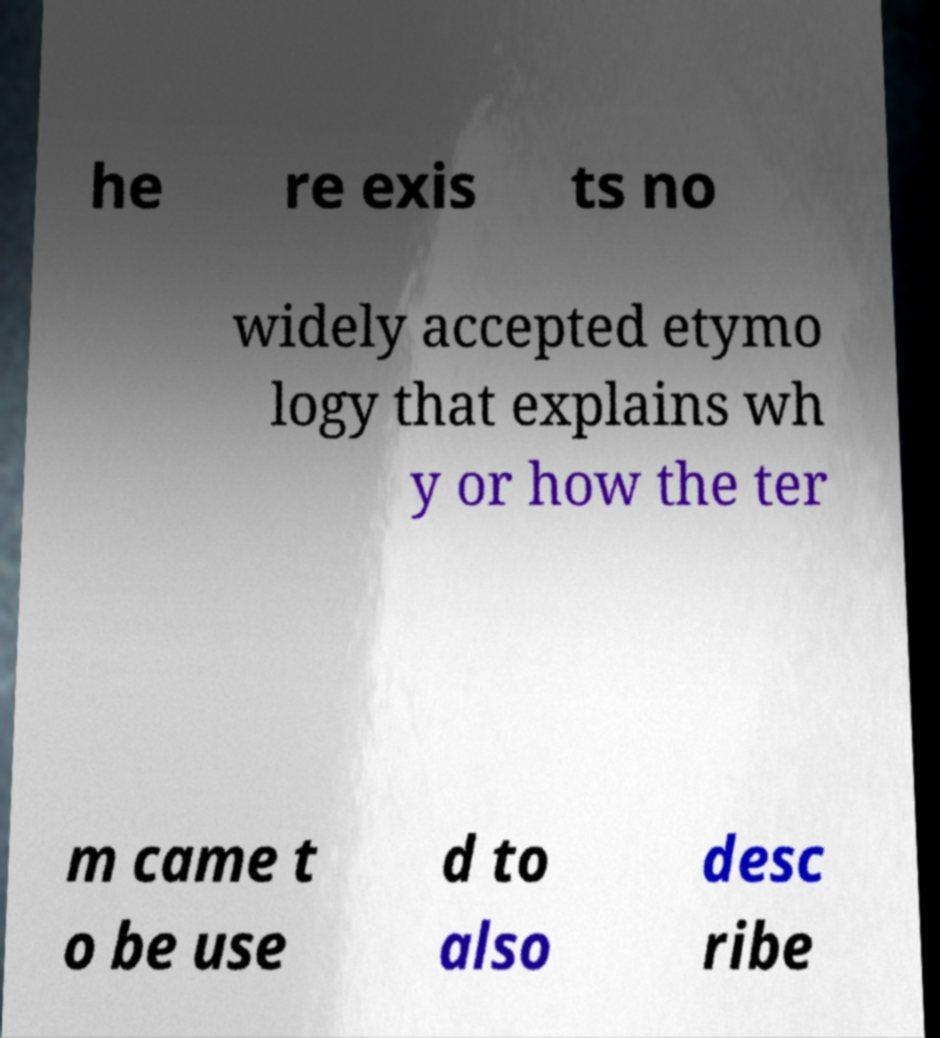Could you assist in decoding the text presented in this image and type it out clearly? he re exis ts no widely accepted etymo logy that explains wh y or how the ter m came t o be use d to also desc ribe 